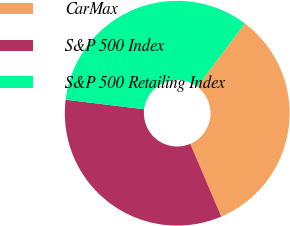Convert chart. <chart><loc_0><loc_0><loc_500><loc_500><pie_chart><fcel>CarMax<fcel>S&P 500 Index<fcel>S&P 500 Retailing Index<nl><fcel>33.3%<fcel>33.33%<fcel>33.37%<nl></chart> 